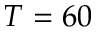<formula> <loc_0><loc_0><loc_500><loc_500>T = 6 0</formula> 